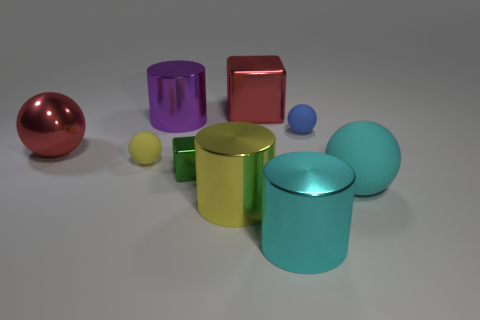Subtract all red balls. How many balls are left? 3 Subtract all purple spheres. Subtract all yellow blocks. How many spheres are left? 4 Add 1 large matte things. How many objects exist? 10 Subtract all cubes. How many objects are left? 7 Subtract all small balls. Subtract all red metallic blocks. How many objects are left? 6 Add 6 yellow metal cylinders. How many yellow metal cylinders are left? 7 Add 2 purple shiny things. How many purple shiny things exist? 3 Subtract 0 blue cylinders. How many objects are left? 9 